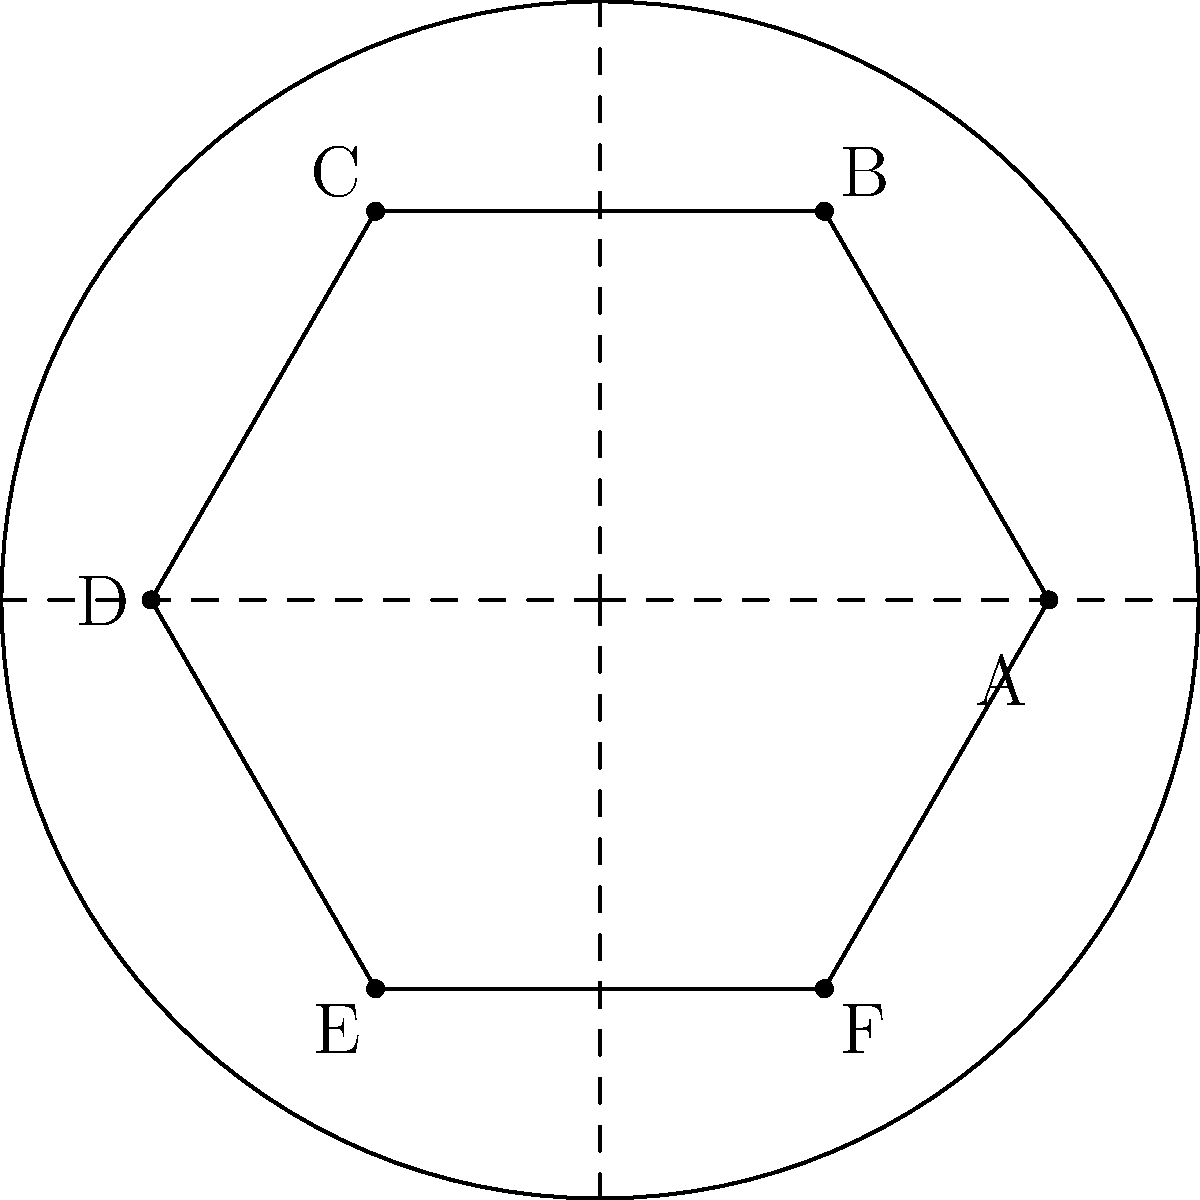In a circular museum space, six interactive language exhibits are to be arranged equidistantly around the perimeter. If the museum has a radius of 8 meters and the exhibits are represented by points A, B, C, D, E, and F as shown in the diagram, what is the distance between two adjacent exhibits? To solve this problem, we'll follow these steps:

1) The exhibits form a regular hexagon inscribed in the circle. The distance between adjacent exhibits is the length of one side of this hexagon.

2) In a regular hexagon, the central angle between two adjacent vertices is 360°/6 = 60°.

3) The radius of the circle bisects this central angle, forming two 30-60-90 triangles.

4) In a 30-60-90 triangle, if the hypotenuse (radius) is $r$, then the shorter leg (half the side of the hexagon) is $r/2$.

5) Given that the radius is 8 meters:
   Half the side length = $8/2 = 4$ meters

6) Therefore, the full side length (distance between adjacent exhibits) is:
   $4 * 2 = 8$ meters

7) We can also verify this using the formula for the side length of a regular hexagon inscribed in a circle:
   $s = r\sqrt{3}$, where $s$ is the side length and $r$ is the radius.
   
   $s = 8\sqrt{3} \approx 13.86$ meters

8) The difference in results is due to rounding in the first method. The second method (using $\sqrt{3}$) is more precise.
Answer: $8\sqrt{3}$ meters 